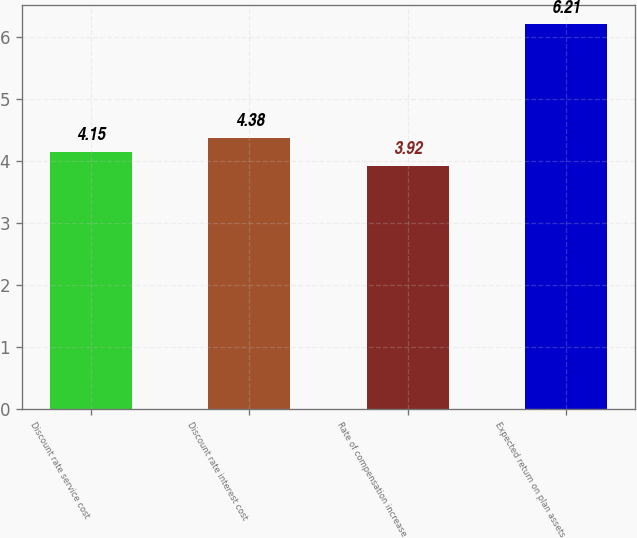Convert chart. <chart><loc_0><loc_0><loc_500><loc_500><bar_chart><fcel>Discount rate service cost<fcel>Discount rate interest cost<fcel>Rate of compensation increase<fcel>Expected return on plan assets<nl><fcel>4.15<fcel>4.38<fcel>3.92<fcel>6.21<nl></chart> 